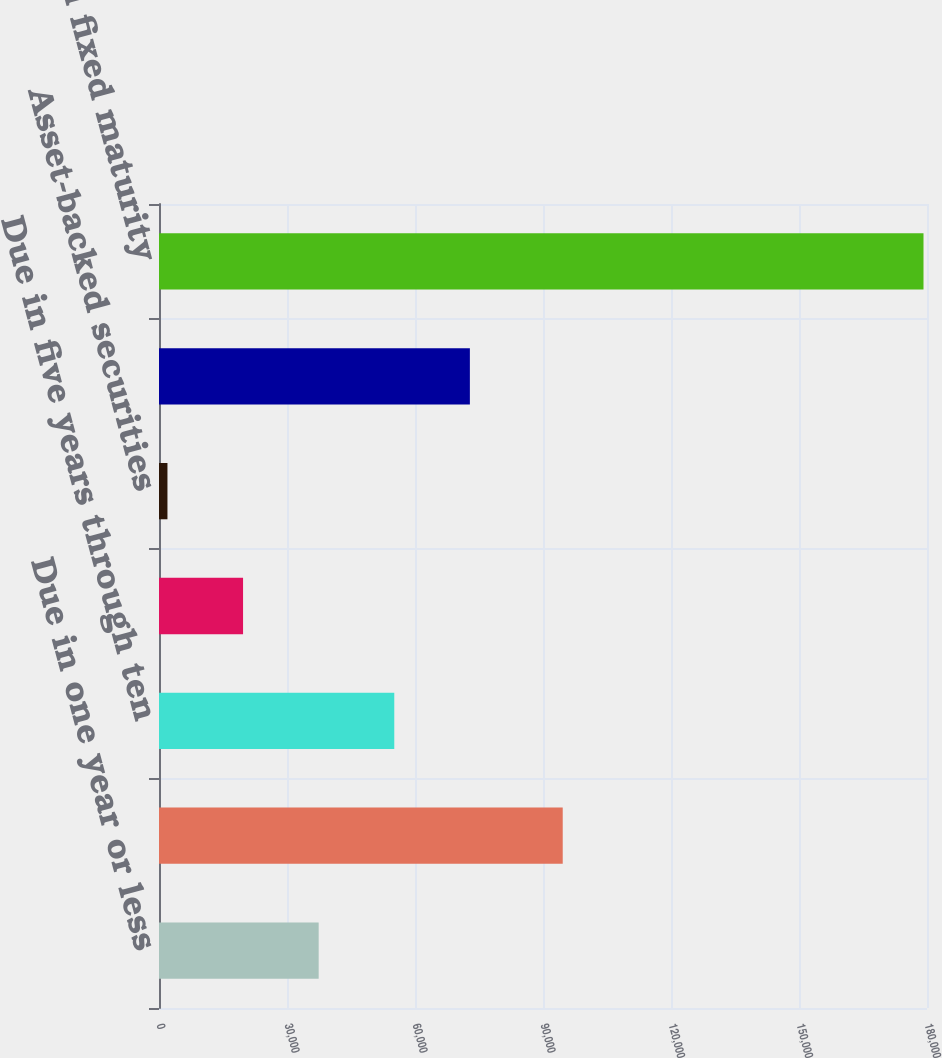Convert chart. <chart><loc_0><loc_0><loc_500><loc_500><bar_chart><fcel>Due in one year or less<fcel>Due in one year through five<fcel>Due in five years through ten<fcel>Due after ten years<fcel>Asset-backed securities<fcel>Mortgage-backed securities<fcel>Total fixed maturity<nl><fcel>37421.8<fcel>94623<fcel>55141.7<fcel>19701.9<fcel>1982<fcel>72861.6<fcel>179181<nl></chart> 